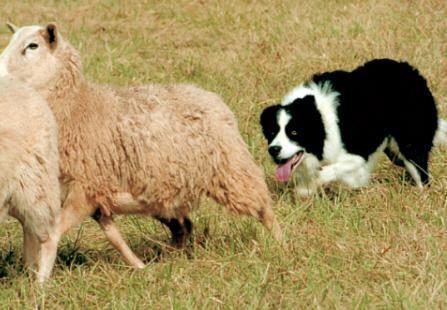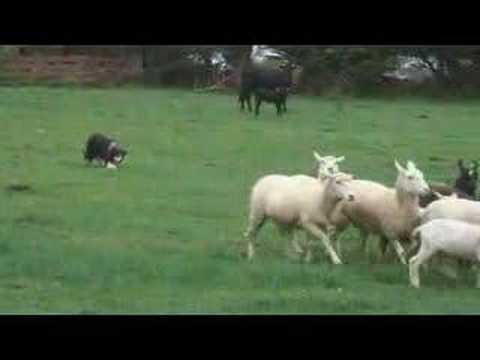The first image is the image on the left, the second image is the image on the right. Examine the images to the left and right. Is the description "One of the images contains exactly three sheep" accurate? Answer yes or no. No. The first image is the image on the left, the second image is the image on the right. For the images displayed, is the sentence "An image shows just one herd dog behind and to the left of a group of sheep." factually correct? Answer yes or no. Yes. 